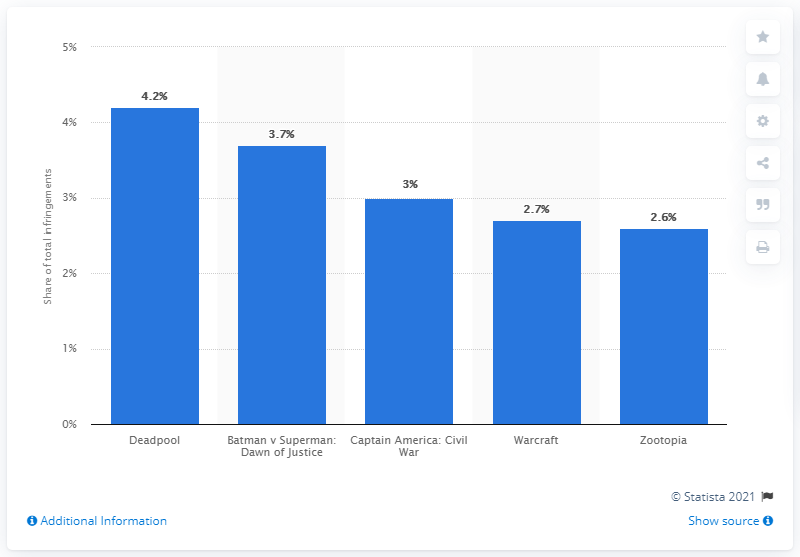List a handful of essential elements in this visual. In the third quarter of 2016, Deadpool accounted for 4.2% of total piracy activity. Deadpool was the most pirated movie in the third quarter of 2016. 